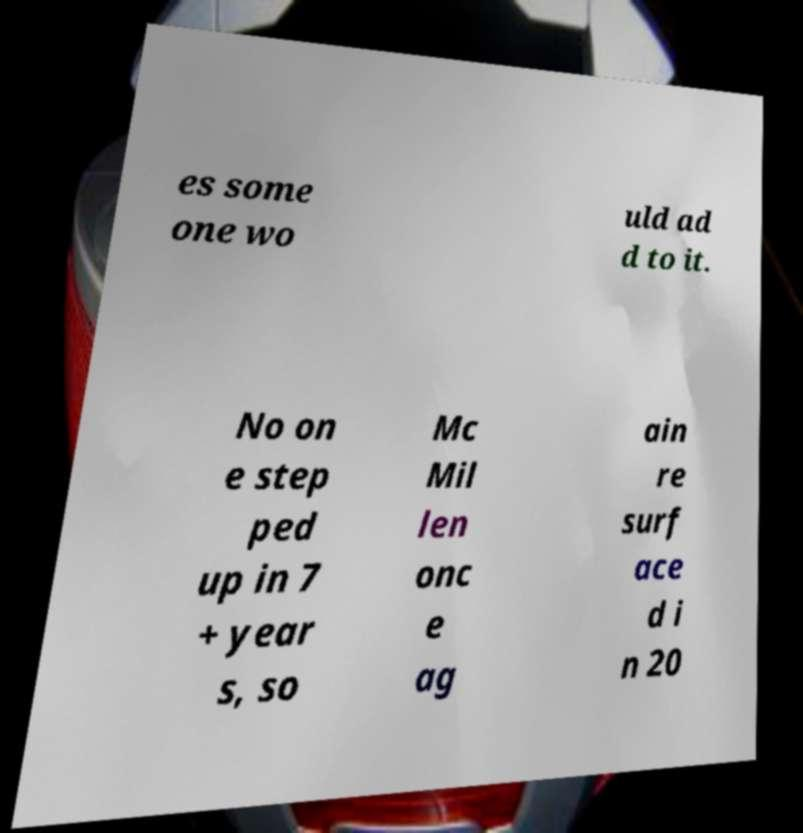Can you accurately transcribe the text from the provided image for me? es some one wo uld ad d to it. No on e step ped up in 7 + year s, so Mc Mil len onc e ag ain re surf ace d i n 20 